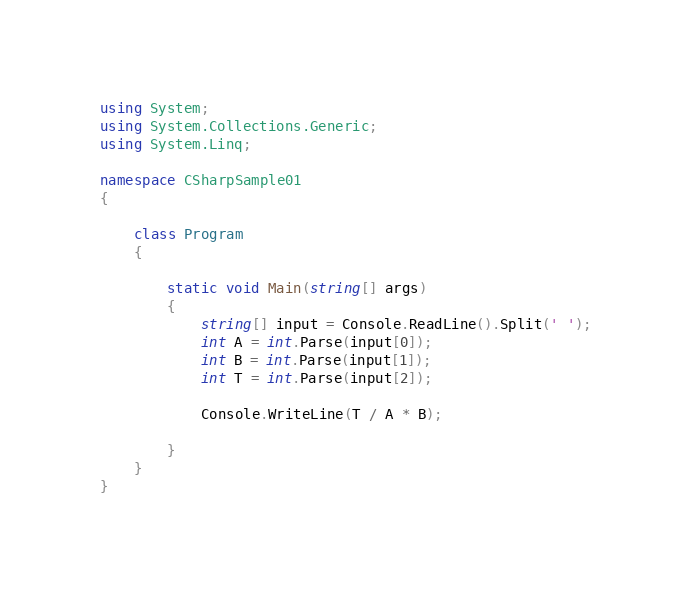<code> <loc_0><loc_0><loc_500><loc_500><_C#_>using System;
using System.Collections.Generic;
using System.Linq;

namespace CSharpSample01
{
    
    class Program
    {
        
        static void Main(string[] args)
        {
            string[] input = Console.ReadLine().Split(' ');
            int A = int.Parse(input[0]);
            int B = int.Parse(input[1]);
            int T = int.Parse(input[2]);

            Console.WriteLine(T / A * B);
            
        }
    }
}
</code> 